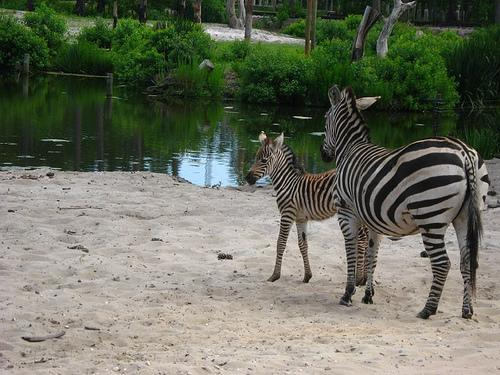Briefly narrate the setting around the zebras, including the natural features and colors present. In a sandy area with green bushes and some brown trees, two zebras are close to dark water with calm reflections of trees. Describe the scene involving the zebras and their physical characteristics. A baby zebra with brown coloring and an adult zebra with black and white stripes are standing in the sandy area. Express the visual of the picture, emphasizing where the zebras are standing and the environment surrounding them. Two striped zebras are standing by a pond, surrounded by the trees and sand near a green bush. Mention the fauna in the image, specifically highlighting their positions, landscape, and vegetation. Amidst a velvety backdrop of sand, green plants, and brown tree trunks, two zebras stand near a serene body of water. Mention the primary animals seen in the image while describing briefly their state, positioning and background context. An adult zebra and its young, by a watering hole, showcase a picturesque scene of sand, green bushes, and trees. Mention the animals present in the picture along with their activity near a specific landmark. Two zebras, a young one and an adult, are standing next to each other by a watering hole. Indicate the dominant color tones and elements in the picture related to the land and water features. A scene of brown earthy sand mixed with white patches, green plants, and reflective dark water displays two zebras. Describe the picture, pointing out the key natural elements, colors, and the location of the main subject of the image. On a canvas of sandy landscape with green vegetation and dark waters, two zebras are beautifully captured. Mention the key highlights of the image that define the relationships between the subjects, their activities and surroundings. Striking reflections, calm water, and sand merge to create a vibrant setting for two zebras standing near the pond. Talk about the effects of any light refraction on the image related to the water. Tree reflections create patterns on the calm, dark water near where two zebras stand. 